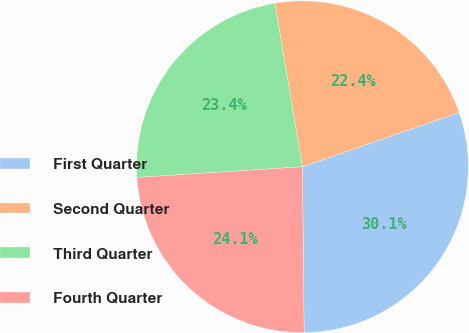Convert chart to OTSL. <chart><loc_0><loc_0><loc_500><loc_500><pie_chart><fcel>First Quarter<fcel>Second Quarter<fcel>Third Quarter<fcel>Fourth Quarter<nl><fcel>30.14%<fcel>22.35%<fcel>23.37%<fcel>24.14%<nl></chart> 